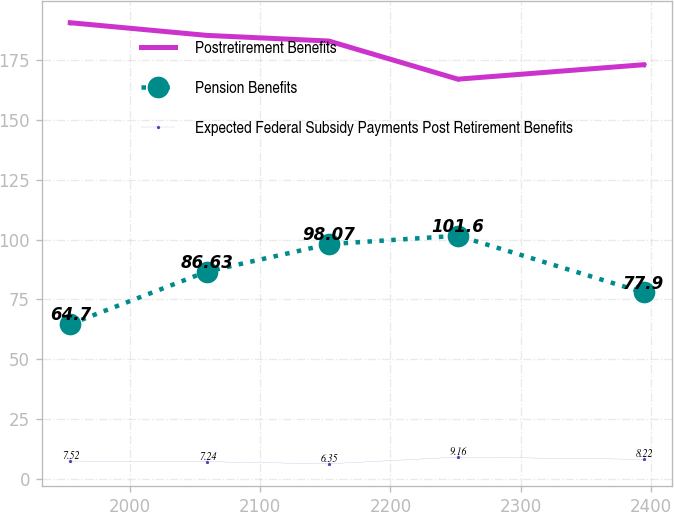Convert chart. <chart><loc_0><loc_0><loc_500><loc_500><line_chart><ecel><fcel>Postretirement Benefits<fcel>Pension Benefits<fcel>Expected Federal Subsidy Payments Post Retirement Benefits<nl><fcel>1954.33<fcel>190.53<fcel>64.7<fcel>7.52<nl><fcel>2059.14<fcel>185.24<fcel>86.63<fcel>7.24<nl><fcel>2152.76<fcel>182.88<fcel>98.07<fcel>6.35<nl><fcel>2251.76<fcel>166.96<fcel>101.6<fcel>9.16<nl><fcel>2394.21<fcel>172.99<fcel>77.9<fcel>8.22<nl></chart> 